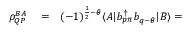<formula> <loc_0><loc_0><loc_500><loc_500>\begin{array} { r l r } { \rho _ { Q P } ^ { B A } } & = } & { ( - 1 ) ^ { \frac { 1 } { 2 } - \theta } \langle A | b _ { p \pi } ^ { \dagger } b _ { q - \theta } | B \rangle = } \end{array}</formula> 